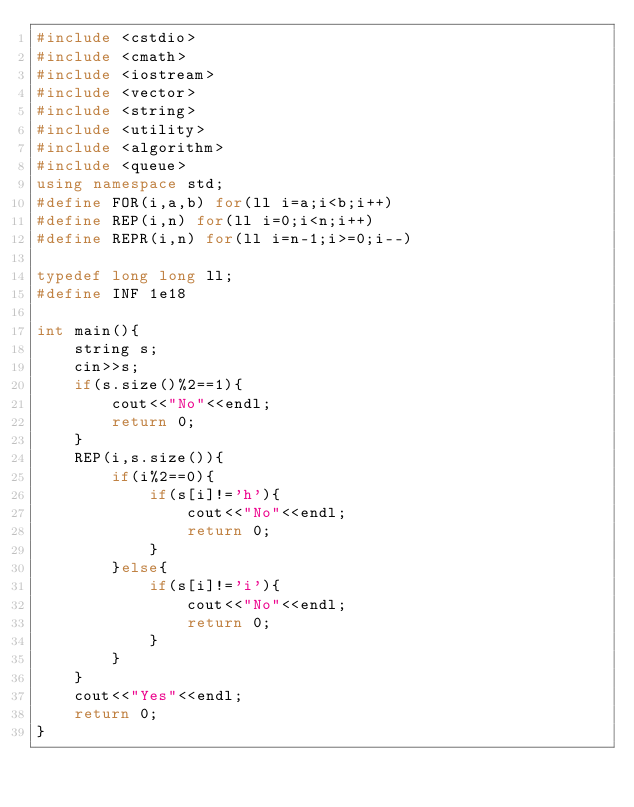<code> <loc_0><loc_0><loc_500><loc_500><_C++_>#include <cstdio>
#include <cmath>
#include <iostream>
#include <vector>
#include <string>
#include <utility>
#include <algorithm>
#include <queue>
using namespace std;
#define FOR(i,a,b) for(ll i=a;i<b;i++)
#define REP(i,n) for(ll i=0;i<n;i++)
#define REPR(i,n) for(ll i=n-1;i>=0;i--)

typedef long long ll;
#define INF 1e18

int main(){
	string s;
	cin>>s;
	if(s.size()%2==1){
		cout<<"No"<<endl;
		return 0;
	}
	REP(i,s.size()){
		if(i%2==0){
			if(s[i]!='h'){
				cout<<"No"<<endl;
				return 0;
			}
		}else{
			if(s[i]!='i'){
				cout<<"No"<<endl;
				return 0;
			}
		}
	}
	cout<<"Yes"<<endl;
	return 0;
}</code> 